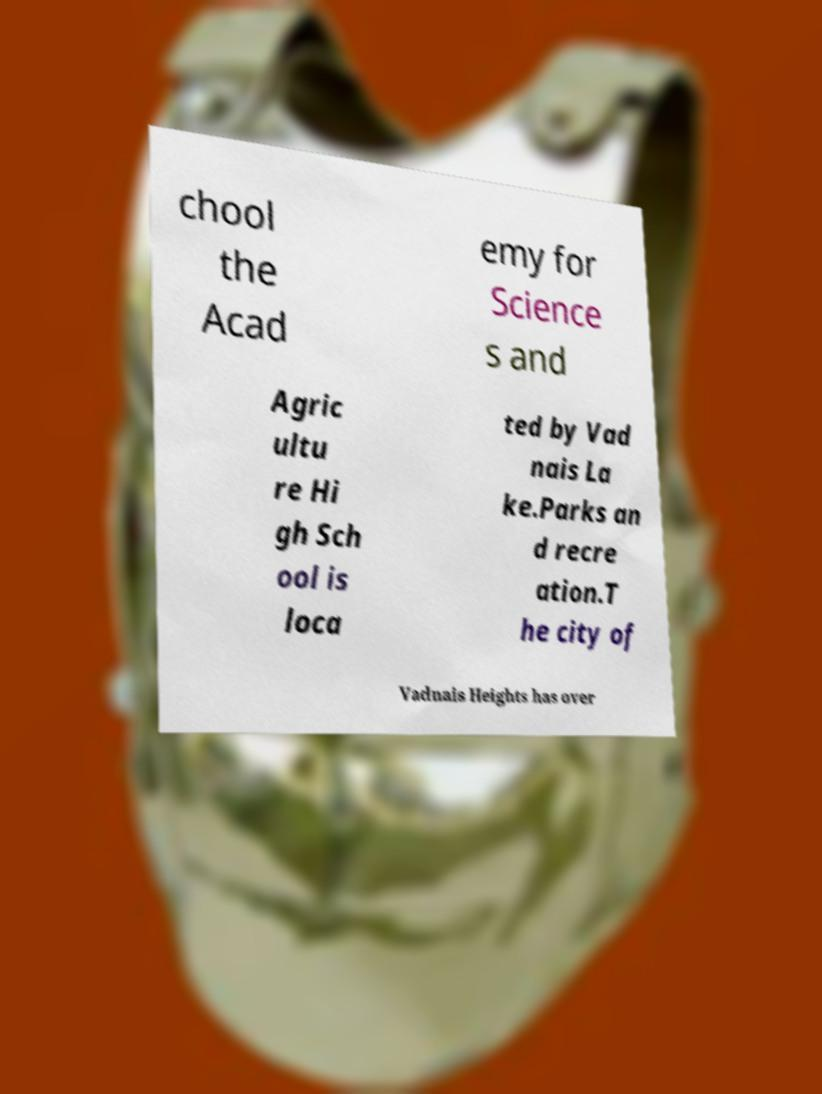For documentation purposes, I need the text within this image transcribed. Could you provide that? chool the Acad emy for Science s and Agric ultu re Hi gh Sch ool is loca ted by Vad nais La ke.Parks an d recre ation.T he city of Vadnais Heights has over 